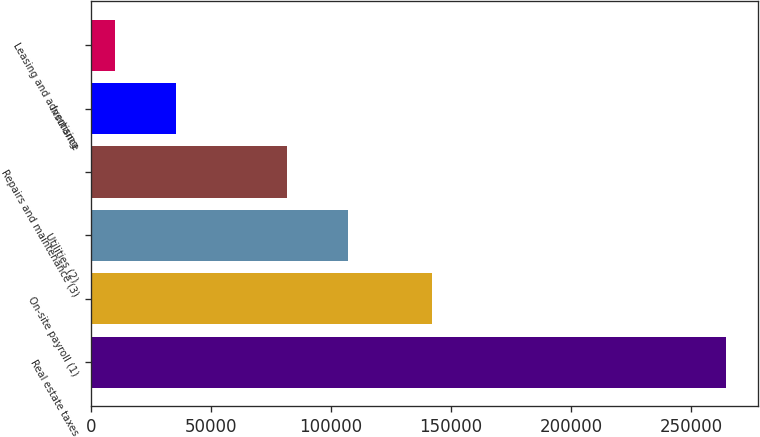Convert chart. <chart><loc_0><loc_0><loc_500><loc_500><bar_chart><fcel>Real estate taxes<fcel>On-site payroll (1)<fcel>Utilities (2)<fcel>Repairs and maintenance (3)<fcel>Insurance<fcel>Leasing and advertising<nl><fcel>264689<fcel>141996<fcel>107076<fcel>81600<fcel>35404.1<fcel>9928<nl></chart> 